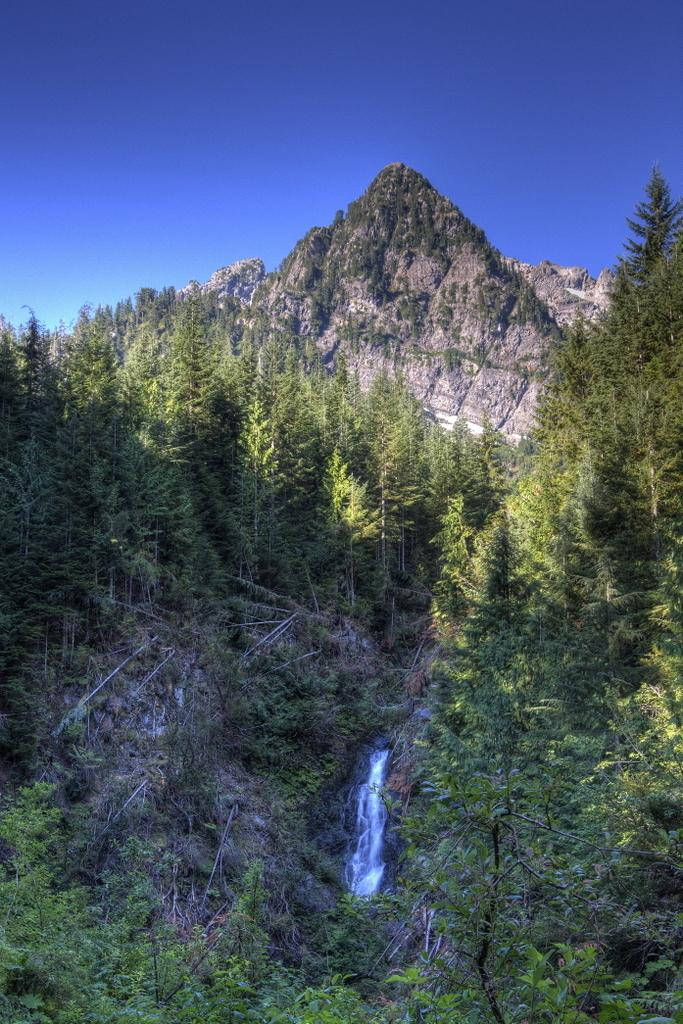What type of vegetation can be seen in the image? There are trees in the image. What natural feature is present in the image? There is a waterfall in the image. What geographical feature is visible in the image? There is a mountain in the image. What is visible at the top of the image? The sky is visible at the top of the image. What type of work is being done by the wave in the image? There is no wave present in the image, so it is not possible to answer that question. 